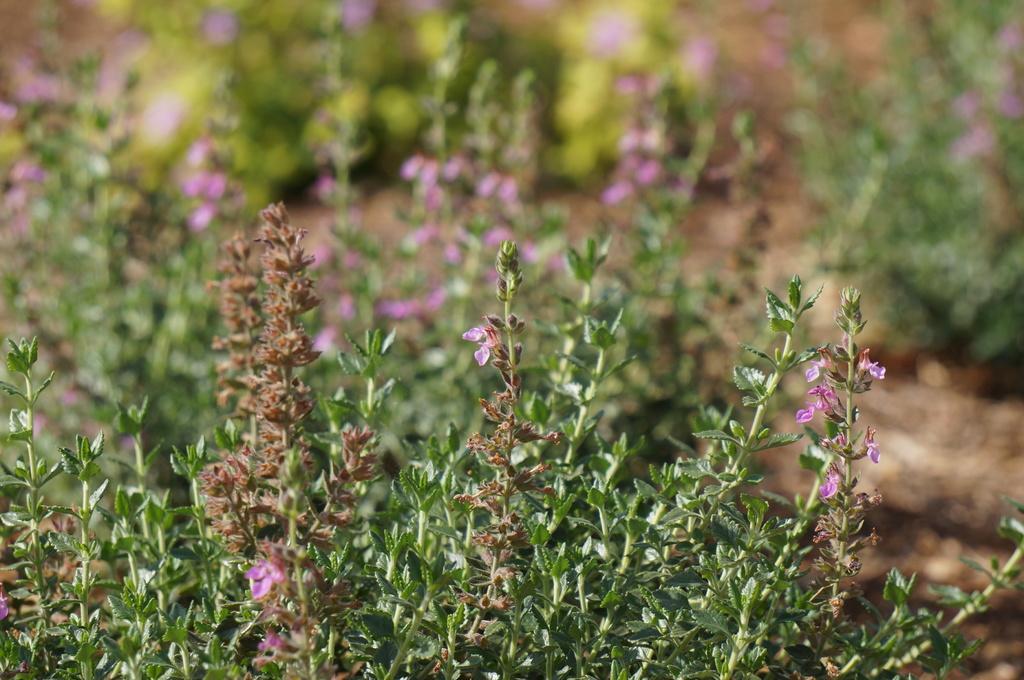Can you describe this image briefly? In this image we can see plants with flowers. 